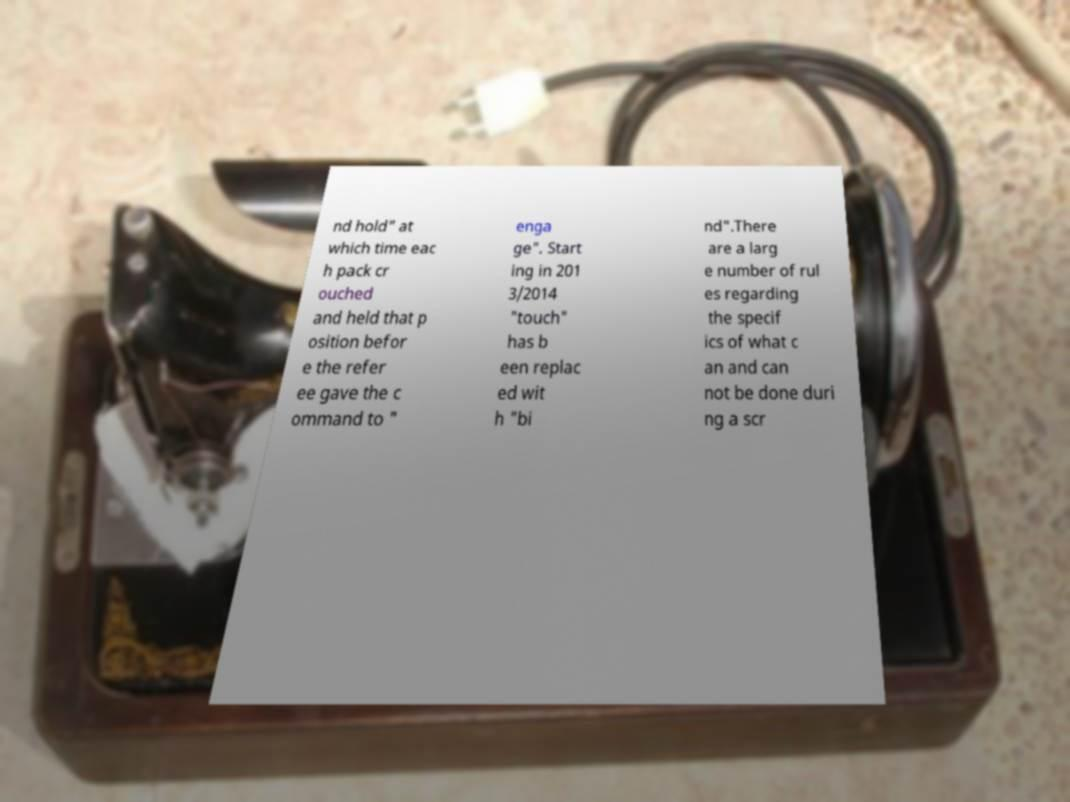Please identify and transcribe the text found in this image. nd hold" at which time eac h pack cr ouched and held that p osition befor e the refer ee gave the c ommand to " enga ge". Start ing in 201 3/2014 "touch" has b een replac ed wit h "bi nd".There are a larg e number of rul es regarding the specif ics of what c an and can not be done duri ng a scr 